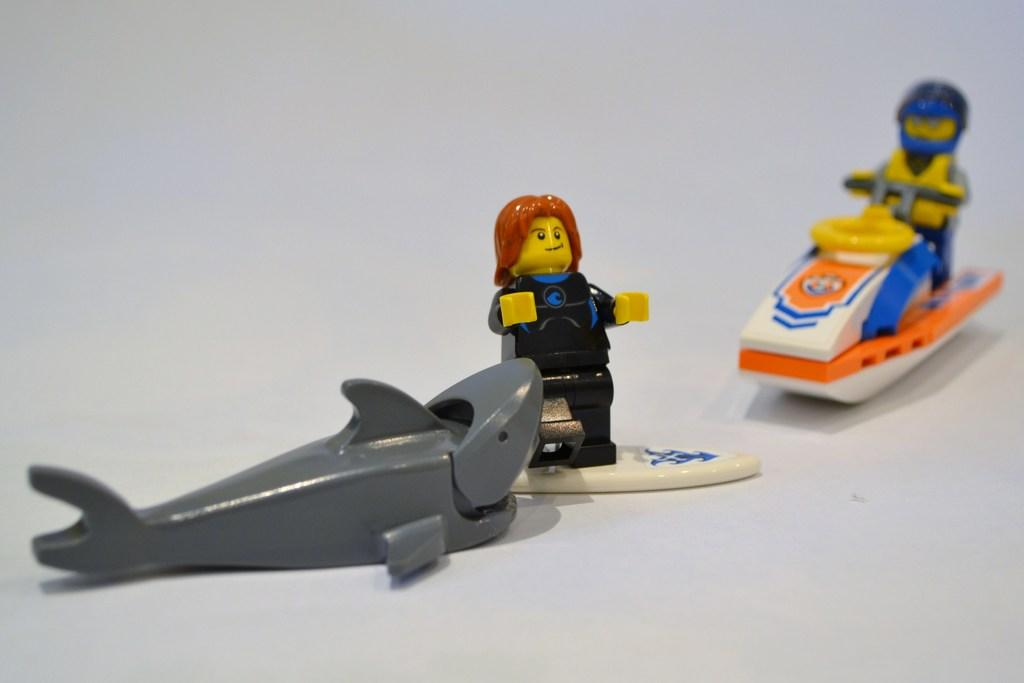What type of toy is in the image? There is a toy shark in the image. What is the toy person doing in the image? There is a toy person standing on a surfboard and another toy person sitting on a motorboat in the image. Can you describe the activities of the toy people in the image? The toy person standing on the surfboard is likely simulating surfing, while the toy person sitting on the motorboat is possibly enjoying a ride. What type of soap is being used to wash the vegetables in the image? There are no soap or vegetables present in the image; it features toy sharks and toy people on a surfboard and motorboat. 